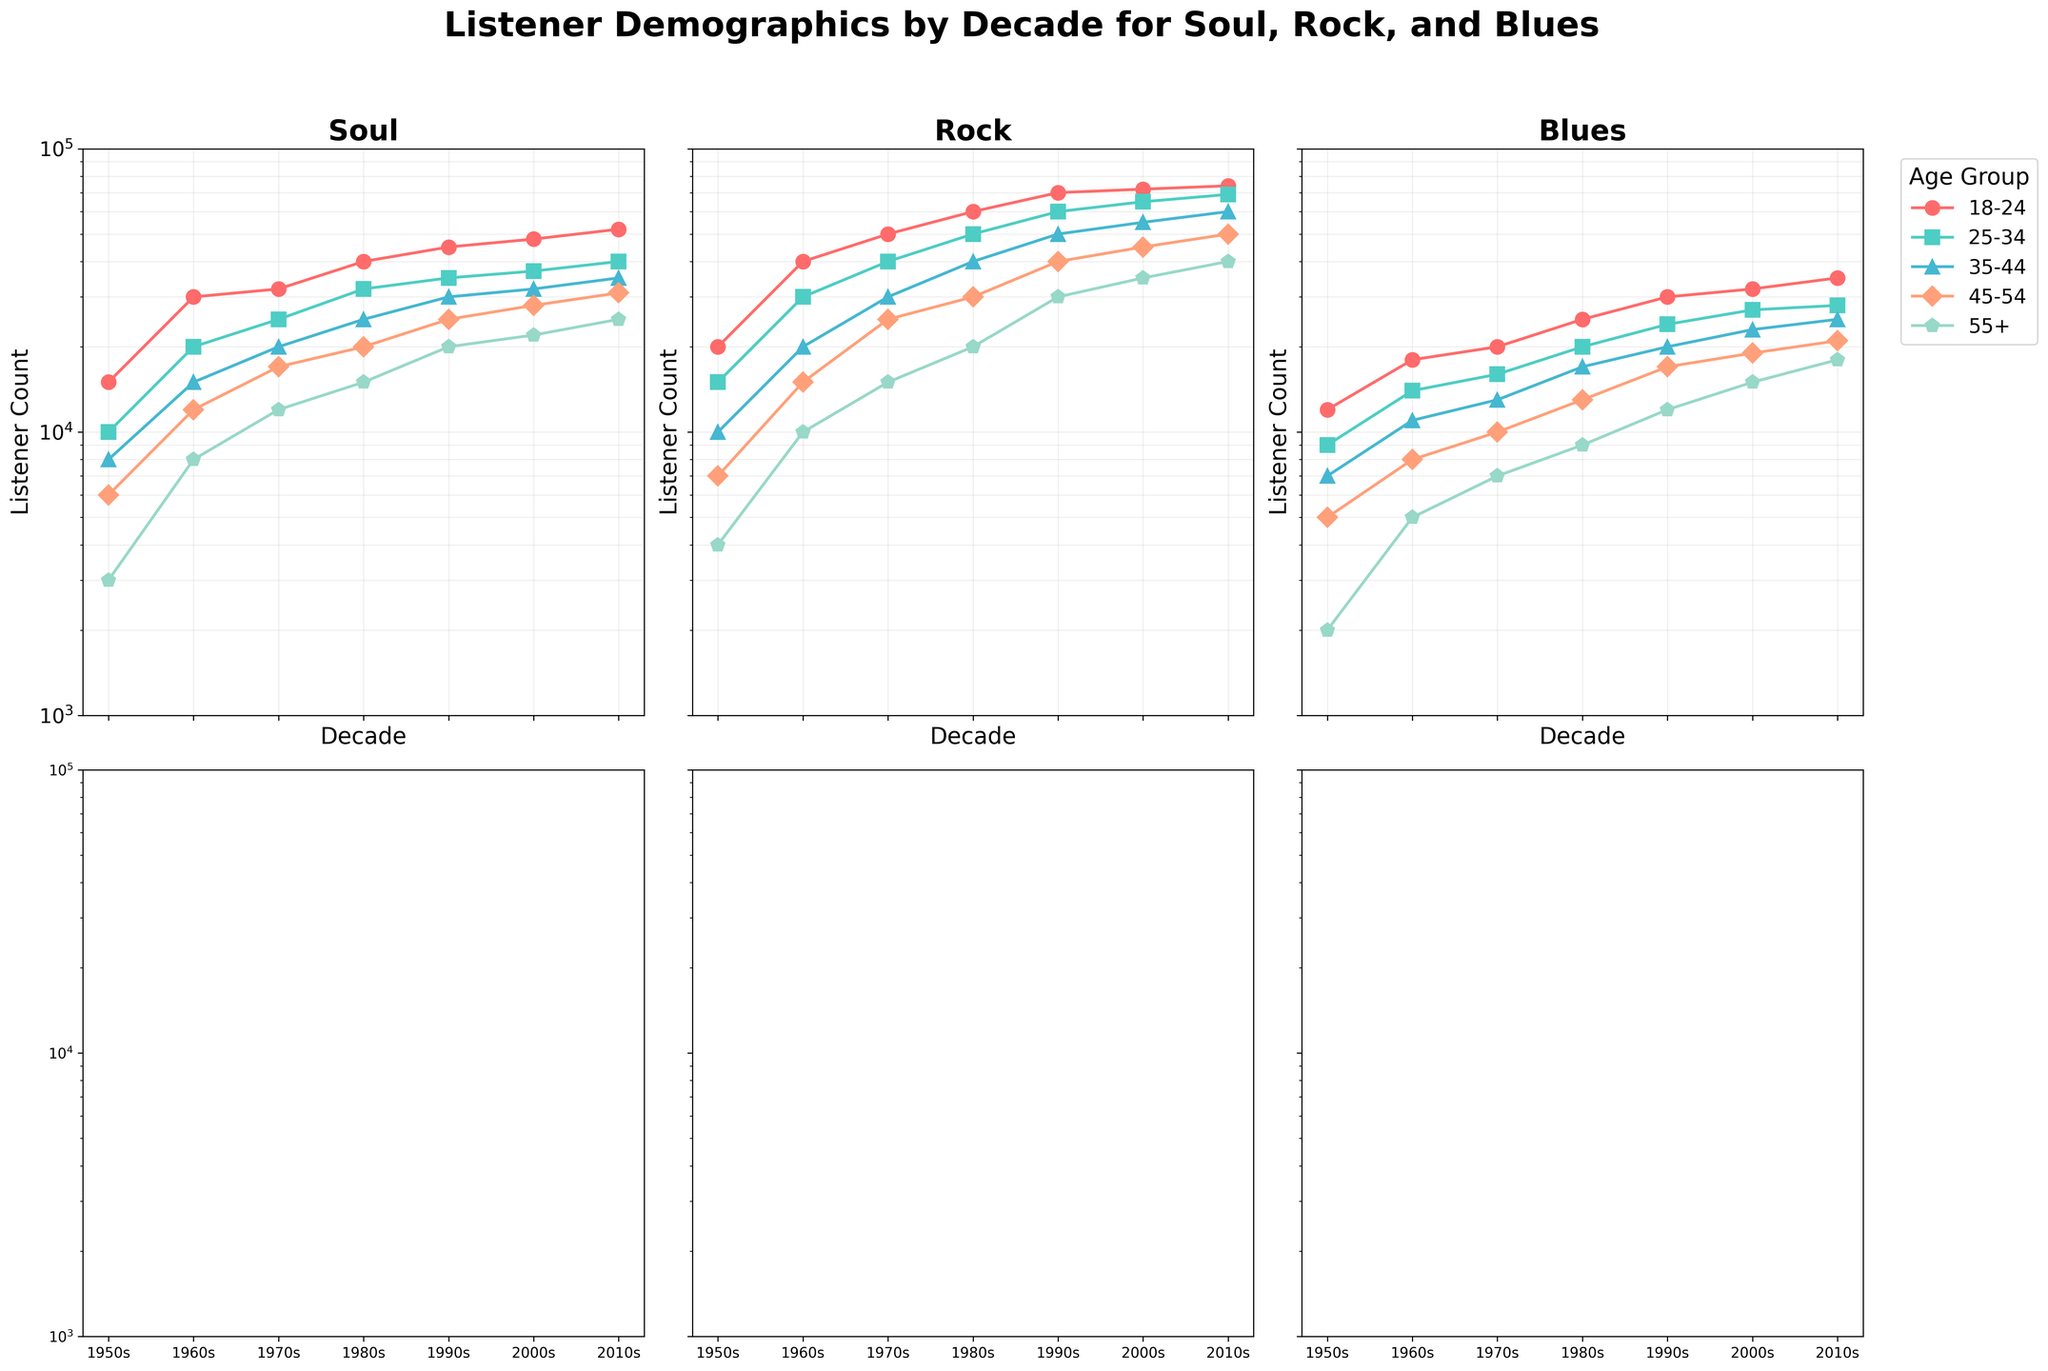What's the title of the figure? The title of the figure is displayed at the top of the figure. Read the title text directly from the figure.
Answer: Listener Demographics by Decade for Soul, Rock, and Blues How many subplots are there in the figure? Look at the number of separate smaller plots within the larger figure. Count each subplot.
Answer: 6 Which genre has the highest number of listeners in the 2010s in the 18-24 age group? Refer to the 2010s section in each subplot and check the listener counts for the 18-24 age group for Soul, Rock, and Blues. Compare the values.
Answer: Rock What is the listener count for the 35-44 age group in Soul in the 1970s? Look at the subplot for Soul. Find the point corresponding to the 1970s and the line representing the 35-44 age group. Note the listener count.
Answer: 20000 Across all decades, which genre generally shows the lowest listener counts for the 55+ age group? Compare the lines for the 55+ age group across all decades and all genres, then identify which genre consistently has the lowest values.
Answer: Blues By how much did the listener count increase from the 1950s to the 2010s for the 25-34 age group in Blues? Check the listener counts for 25-34 age group in the Blues subplot for both 1950s and 2010s. Subtract the 1950s count from the 2010s count to find the increase.
Answer: 19000 Between which two decades did the listener count for the 45-54 age group in Rock see the largest increase? Identify the listener counts for the 45-54 age group in Rock across all decades in the Rock subplot. Calculate the increase between each consecutive decade, and determine the largest increase.
Answer: 1980s to 1990s Which age group showed the least variation in listener counts over time for Soul music? Examine the subplot for Soul and compare the lines representing each age group. Identify the age group with the flattest line.
Answer: 45-54 In the 1960s, which genre had the highest overall listener count when summing all age groups? For each genre in the 1960s, add up the listener counts from all age groups. Compare the sums to determine the genre with the highest overall count.
Answer: Rock How has the listener count trend for the 35-44 age group evolved for Blues from the 1950s to the 2010s? Observe the line representing the 35-44 age group in the Blues subplot. Describe its trend (increasing, decreasing, or fluctuating) from the 1950s to the 2010s.
Answer: Increasing 